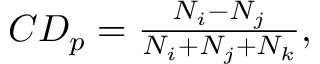<formula> <loc_0><loc_0><loc_500><loc_500>\begin{array} { r } { C D _ { p } = \frac { N _ { i } - N _ { j } } { N _ { i } + N _ { j } + N _ { k } } , } \end{array}</formula> 